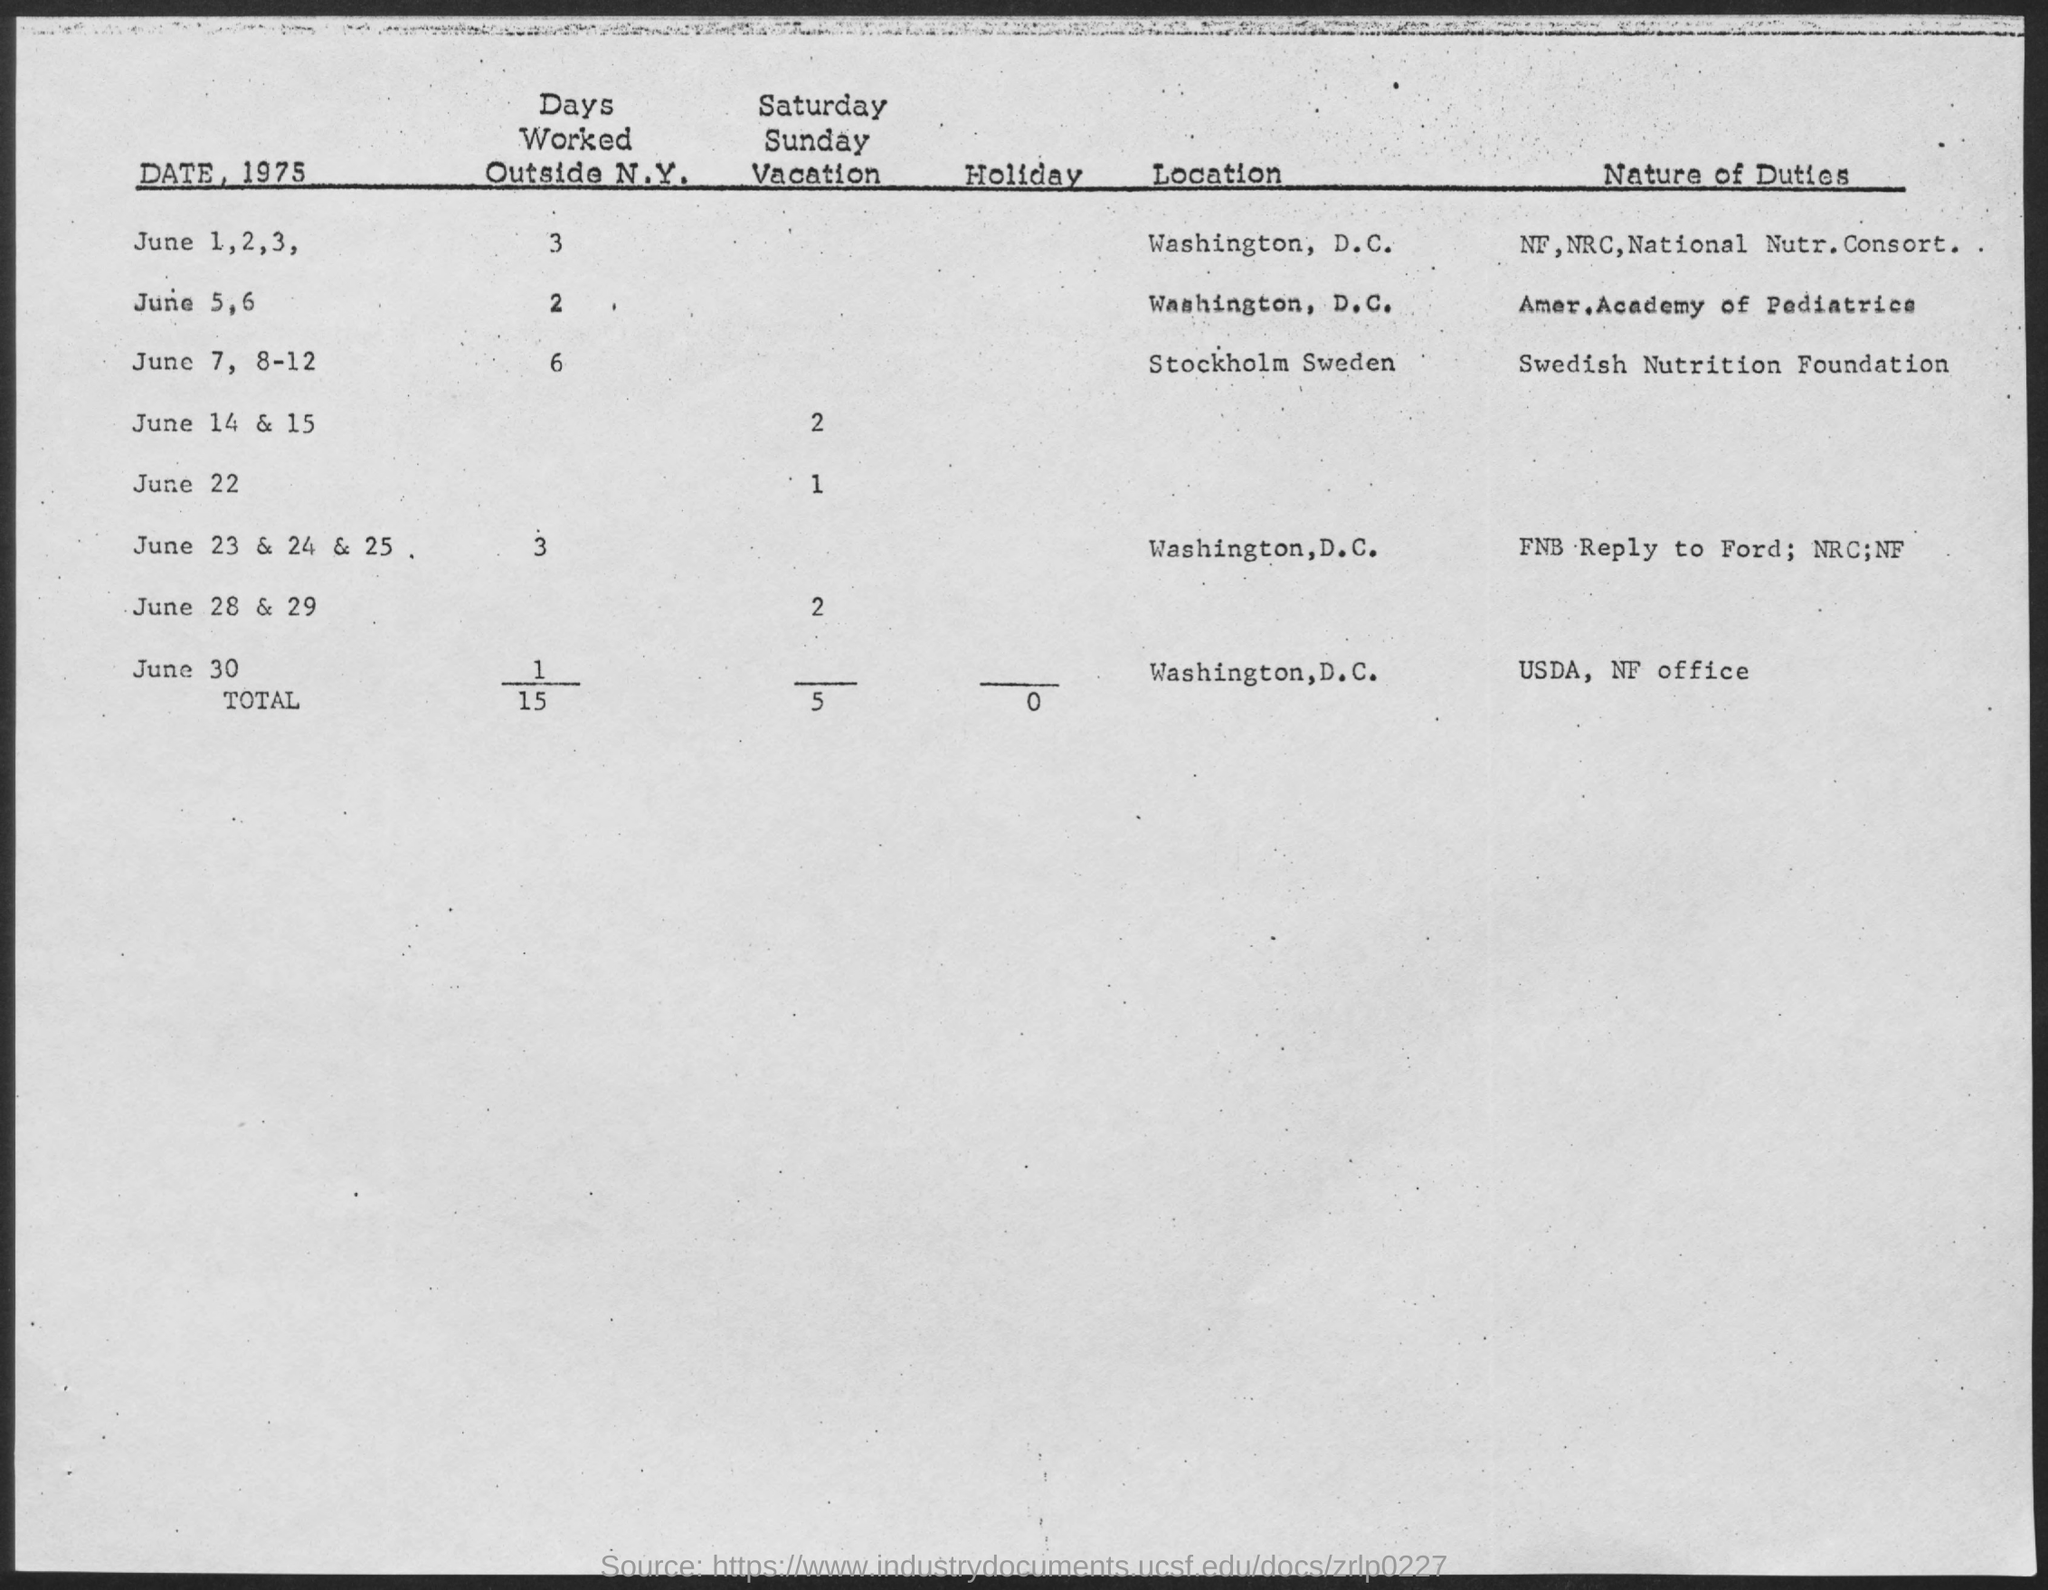What is the total number of days worked outside N.Y.?
Ensure brevity in your answer.  15. What is the nature of duty on June 7,8-12?
Make the answer very short. Swedish nutrition foundation. What is the location on June 7,8-12?
Offer a very short reply. Stockholm sweden. What is the nature of duty on June 5,6?
Provide a short and direct response. Amer.Academy of Pediatrics. What is the total number of Holidays?
Provide a succinct answer. 0. On which date location is Stockholm Sweden?
Provide a short and direct response. June 7, 8-12. 